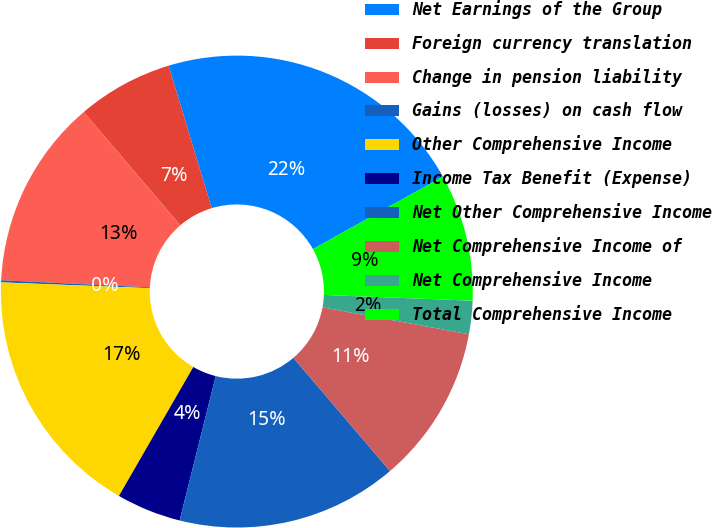Convert chart. <chart><loc_0><loc_0><loc_500><loc_500><pie_chart><fcel>Net Earnings of the Group<fcel>Foreign currency translation<fcel>Change in pension liability<fcel>Gains (losses) on cash flow<fcel>Other Comprehensive Income<fcel>Income Tax Benefit (Expense)<fcel>Net Other Comprehensive Income<fcel>Net Comprehensive Income of<fcel>Net Comprehensive Income<fcel>Total Comprehensive Income<nl><fcel>21.57%<fcel>6.57%<fcel>13.0%<fcel>0.14%<fcel>17.29%<fcel>4.43%<fcel>15.14%<fcel>10.86%<fcel>2.28%<fcel>8.71%<nl></chart> 